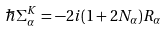Convert formula to latex. <formula><loc_0><loc_0><loc_500><loc_500>\hbar { \Sigma } ^ { K } _ { \alpha } = - 2 i ( 1 + 2 N _ { \alpha } ) R _ { \alpha }</formula> 